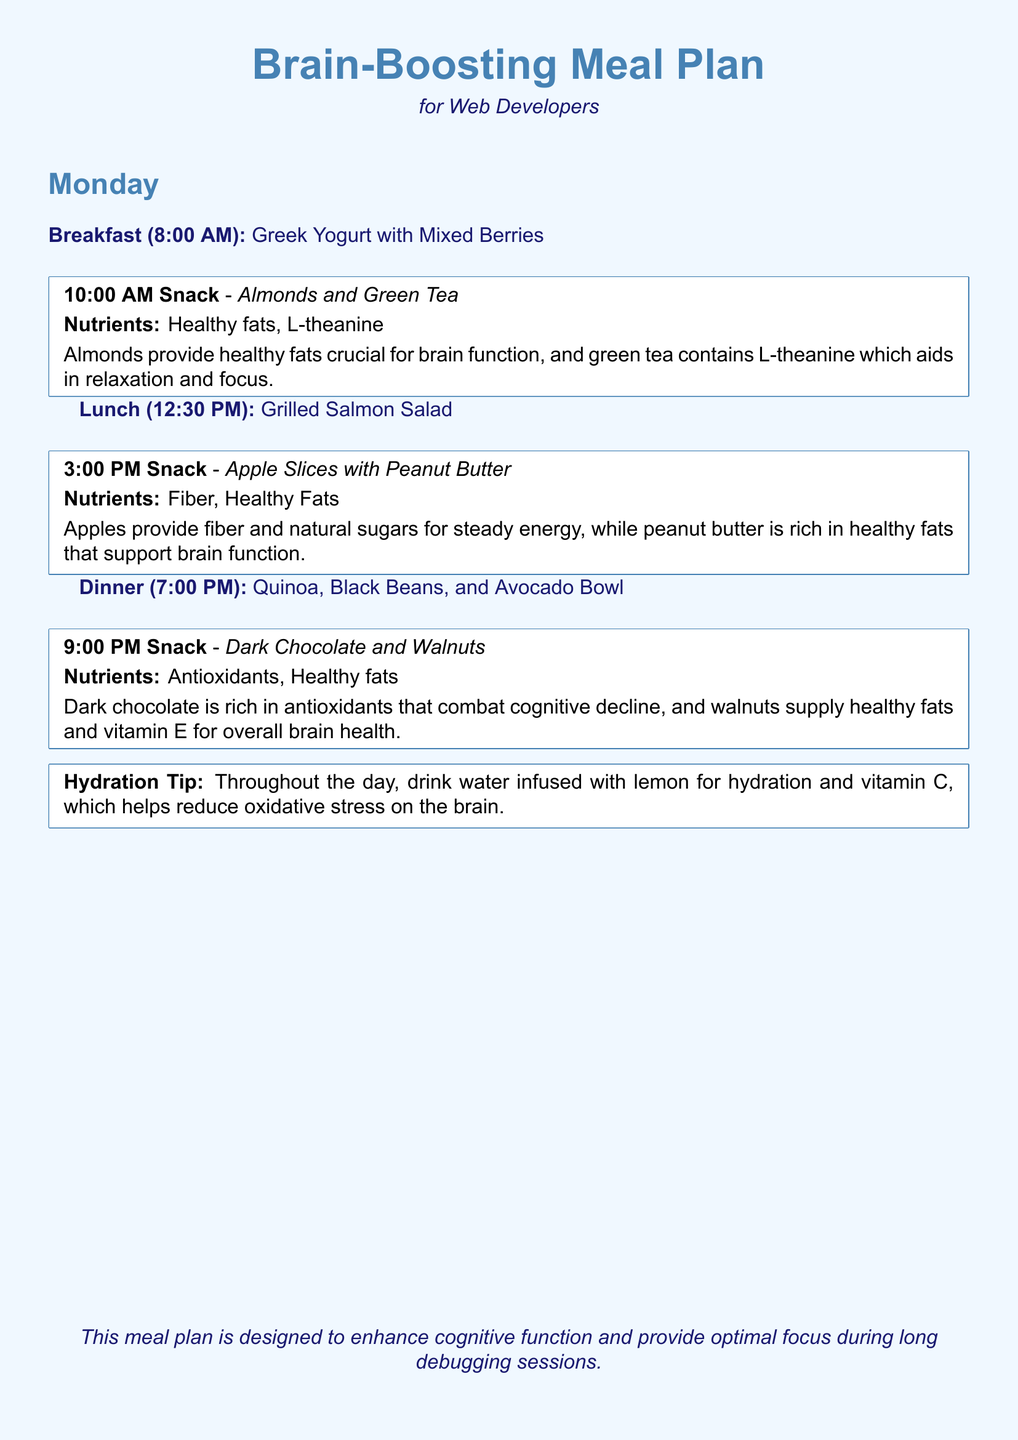What is the title of the meal plan? The document's title is presented at the top and describes the focus of the meal plan.
Answer: Brain-Boosting Meal Plan What is the first meal listed for Monday? The first meal is specified in the schedule under Monday.
Answer: Greek Yogurt with Mixed Berries What time is the 10:00 AM snack? The time for the snack is indicated as part of the schedule.
Answer: 10:00 AM Which nutrient is associated with Almonds and Green Tea? The nutrients provided are listed with the meal items.
Answer: Healthy fats, L-theanine What food item is included in the 3:00 PM snack? The specific food for the snack is detailed in the daily schedule.
Answer: Apple Slices with Peanut Butter What is the hydration tip mentioned in the document? The hydration tip is described in its own separate box, offering guidance on water consumption.
Answer: Drink water infused with lemon How many total meals are listed for Monday? The total number of meals is counted from the daily meal schedule.
Answer: Four What is the main ingredient in the lunch meal? The main ingredient is located in the details of the lunch section.
Answer: Grilled Salmon What is the last snack item for Monday? The document lists the last snack at the end of Monday's meal plan.
Answer: Dark Chocolate and Walnuts 